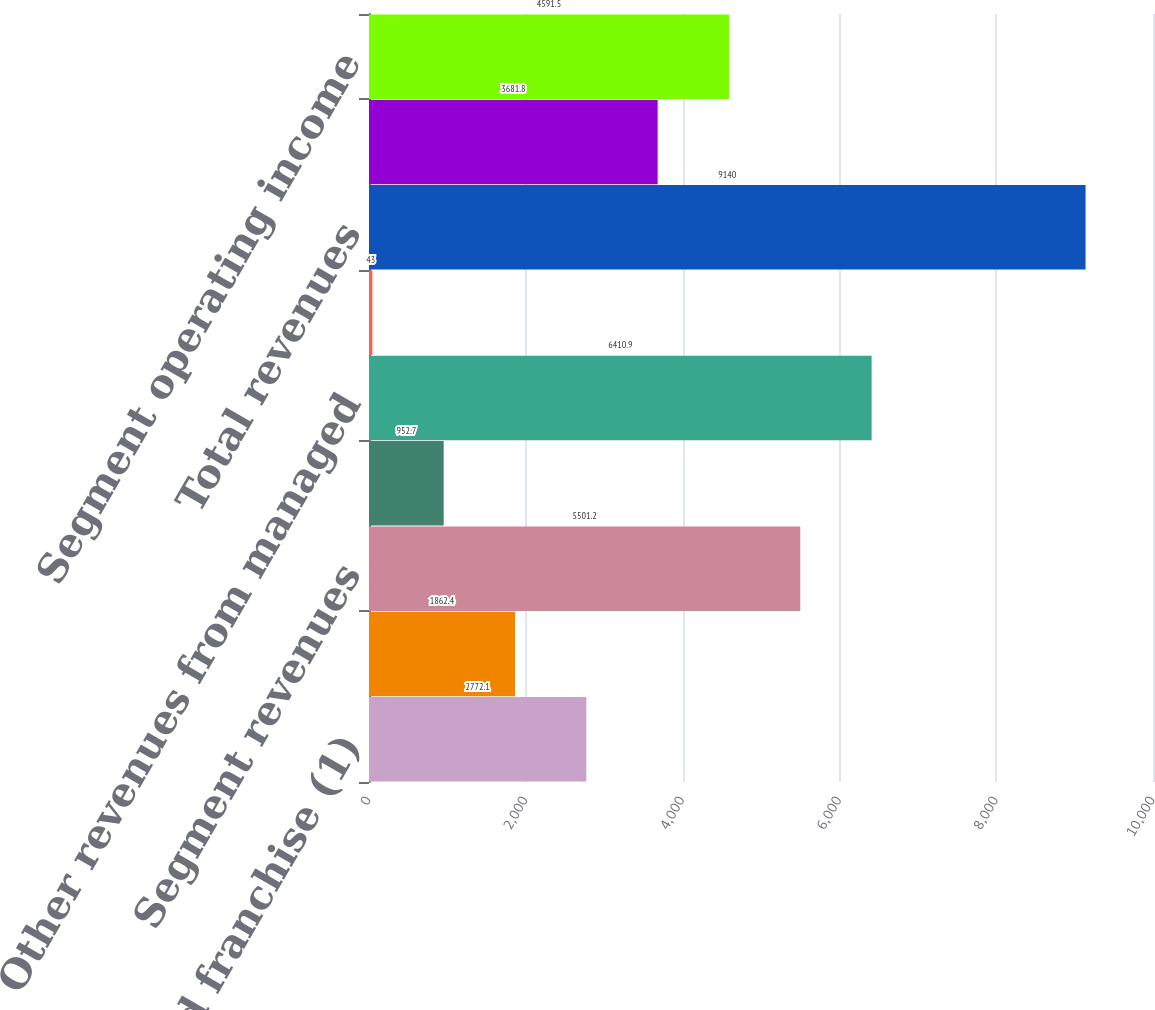Convert chart to OTSL. <chart><loc_0><loc_0><loc_500><loc_500><bar_chart><fcel>Management and franchise (1)<fcel>Ownership<fcel>Segment revenues<fcel>Other revenues<fcel>Other revenues from managed<fcel>Intersegment fees elimination<fcel>Total revenues<fcel>Management and franchise<fcel>Segment operating income<nl><fcel>2772.1<fcel>1862.4<fcel>5501.2<fcel>952.7<fcel>6410.9<fcel>43<fcel>9140<fcel>3681.8<fcel>4591.5<nl></chart> 